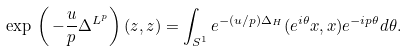Convert formula to latex. <formula><loc_0><loc_0><loc_500><loc_500>\exp \, \left ( \, - \frac { u } { p } \Delta ^ { L ^ { p } } \right ) ( z , z ) = \int _ { S ^ { 1 } } e ^ { - ( u / p ) \Delta _ { H } } ( e ^ { i \theta } x , x ) e ^ { - i p \theta } d \theta .</formula> 